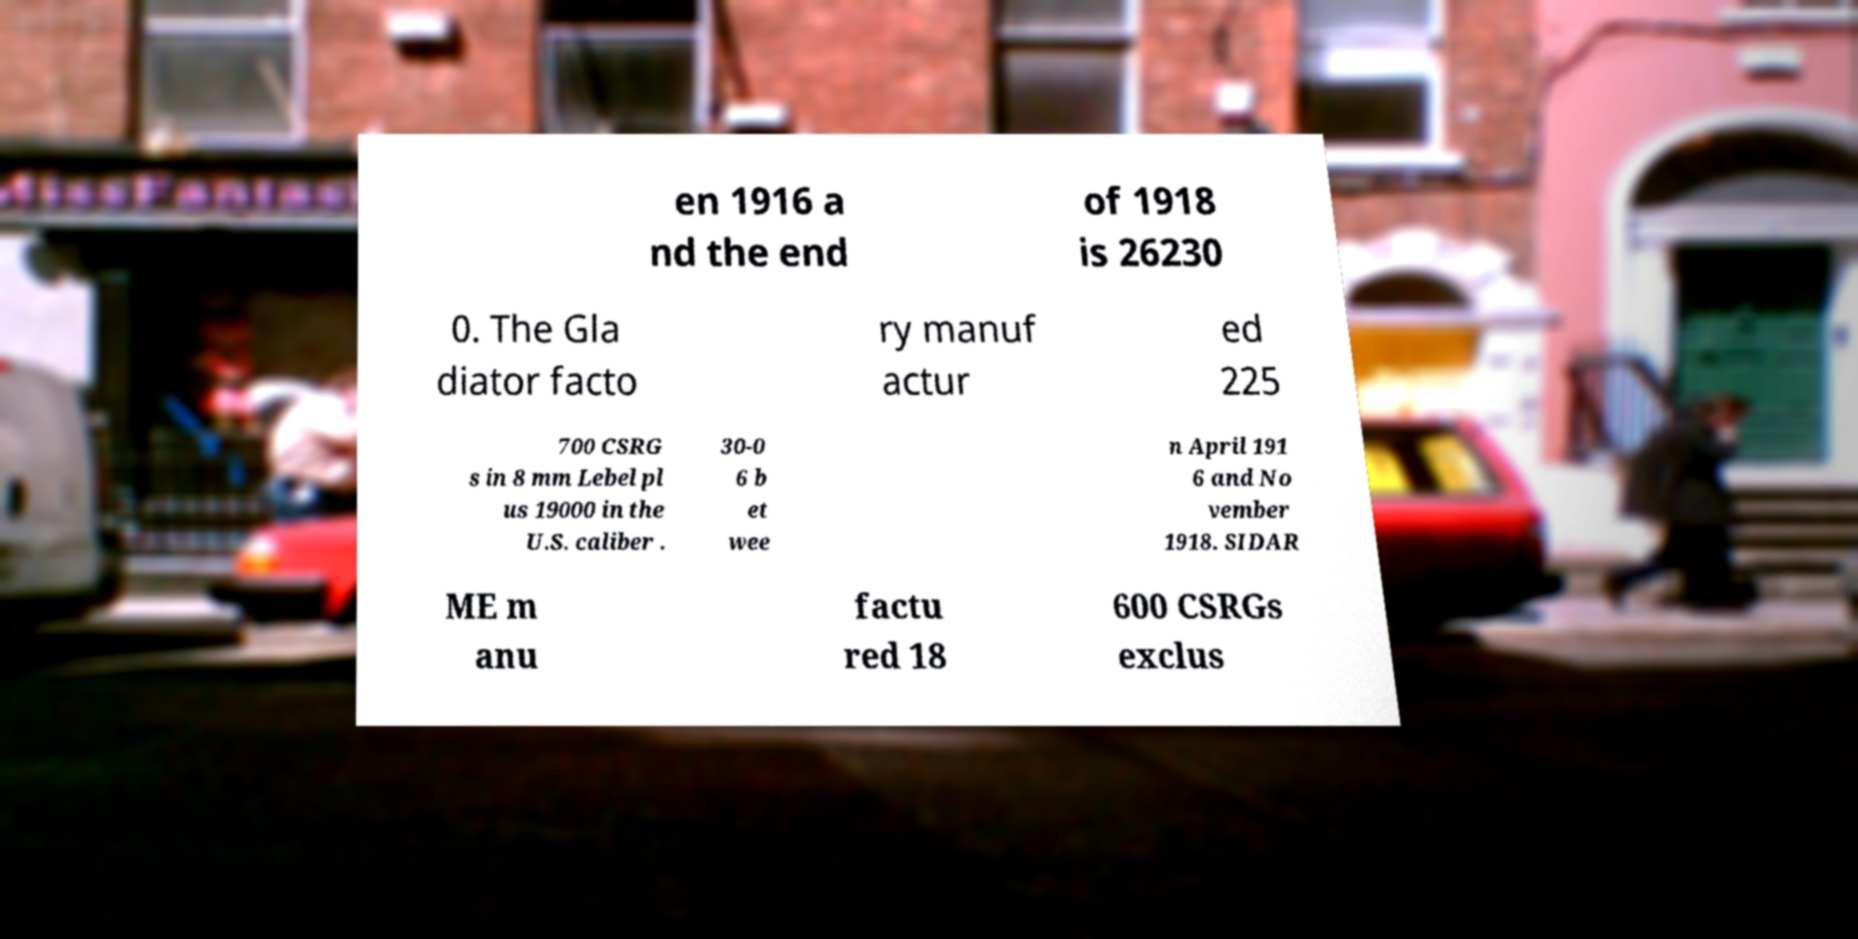Please identify and transcribe the text found in this image. en 1916 a nd the end of 1918 is 26230 0. The Gla diator facto ry manuf actur ed 225 700 CSRG s in 8 mm Lebel pl us 19000 in the U.S. caliber . 30-0 6 b et wee n April 191 6 and No vember 1918. SIDAR ME m anu factu red 18 600 CSRGs exclus 